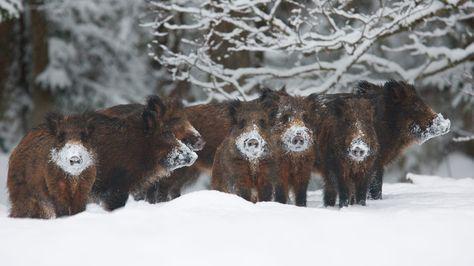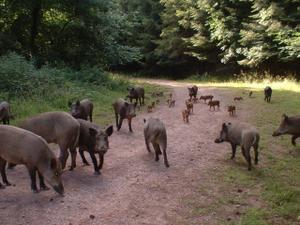The first image is the image on the left, the second image is the image on the right. For the images displayed, is the sentence "Trees with green branches are behind a group of hogs in one image." factually correct? Answer yes or no. Yes. The first image is the image on the left, the second image is the image on the right. Considering the images on both sides, is "There are exactly three animals in the image on the right." valid? Answer yes or no. No. 